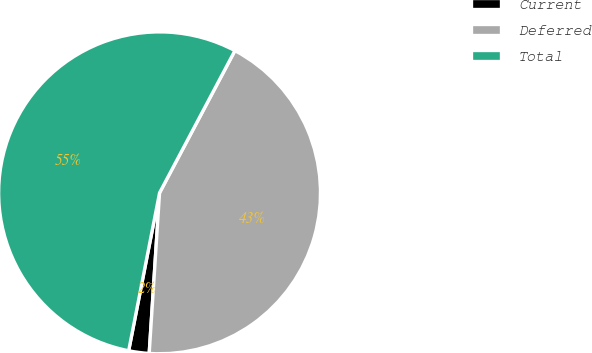Convert chart. <chart><loc_0><loc_0><loc_500><loc_500><pie_chart><fcel>Current<fcel>Deferred<fcel>Total<nl><fcel>2.05%<fcel>43.27%<fcel>54.68%<nl></chart> 